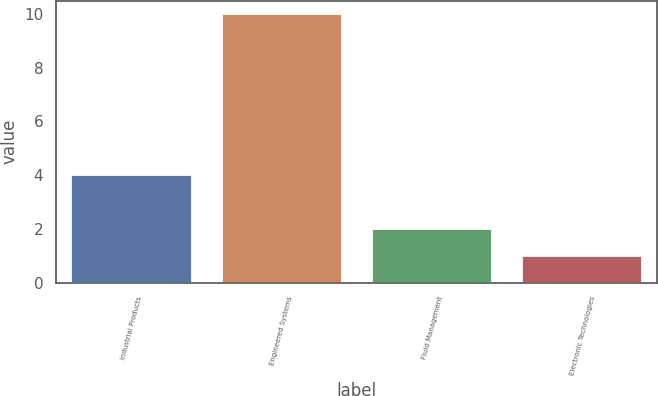Convert chart. <chart><loc_0><loc_0><loc_500><loc_500><bar_chart><fcel>Industrial Products<fcel>Engineered Systems<fcel>Fluid Management<fcel>Electronic Technologies<nl><fcel>4<fcel>10<fcel>2<fcel>1<nl></chart> 